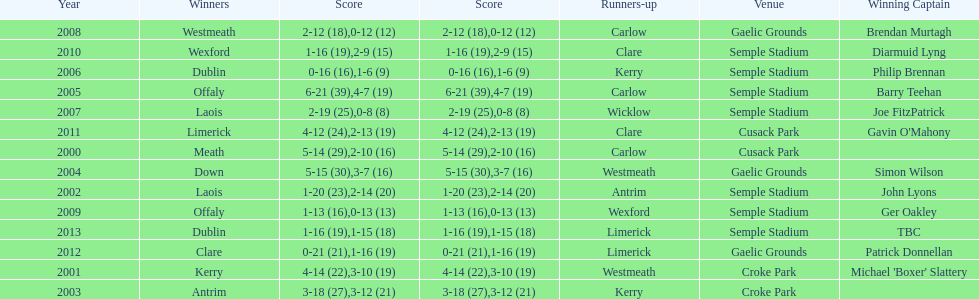Who was the winning captain the last time the competition was held at the gaelic grounds venue? Patrick Donnellan. 